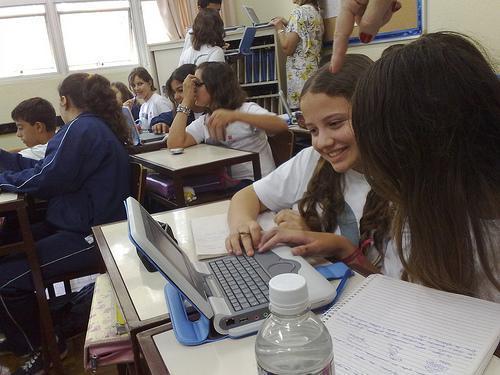How many laptops are in the foreground?
Give a very brief answer. 1. How many girls are using the laptop in the foreground of the picture?
Give a very brief answer. 2. How many water bottles are there?
Give a very brief answer. 1. 